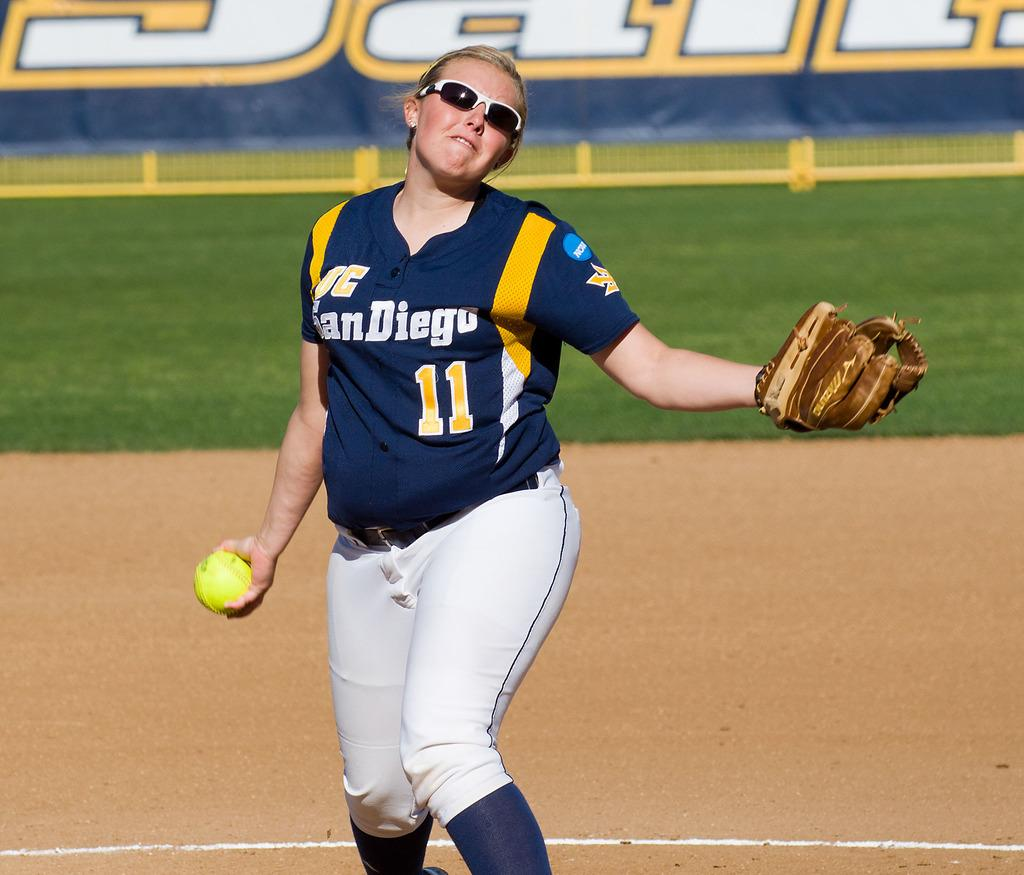Provide a one-sentence caption for the provided image. A female sports player wearing a shirt reading san diego 11. 